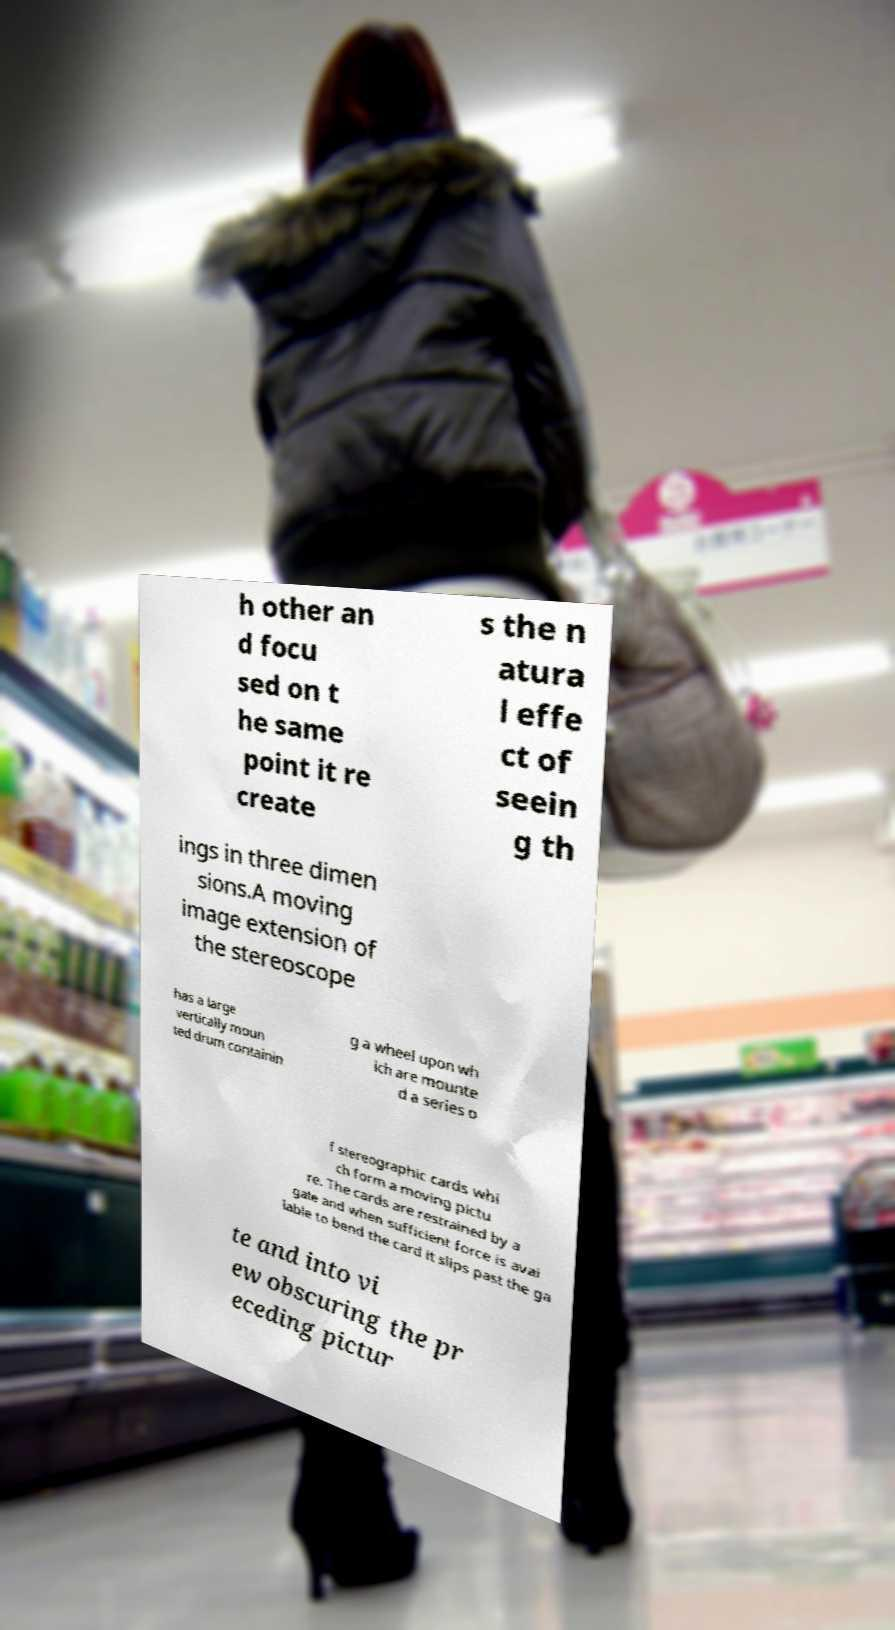I need the written content from this picture converted into text. Can you do that? h other an d focu sed on t he same point it re create s the n atura l effe ct of seein g th ings in three dimen sions.A moving image extension of the stereoscope has a large vertically moun ted drum containin g a wheel upon wh ich are mounte d a series o f stereographic cards whi ch form a moving pictu re. The cards are restrained by a gate and when sufficient force is avai lable to bend the card it slips past the ga te and into vi ew obscuring the pr eceding pictur 